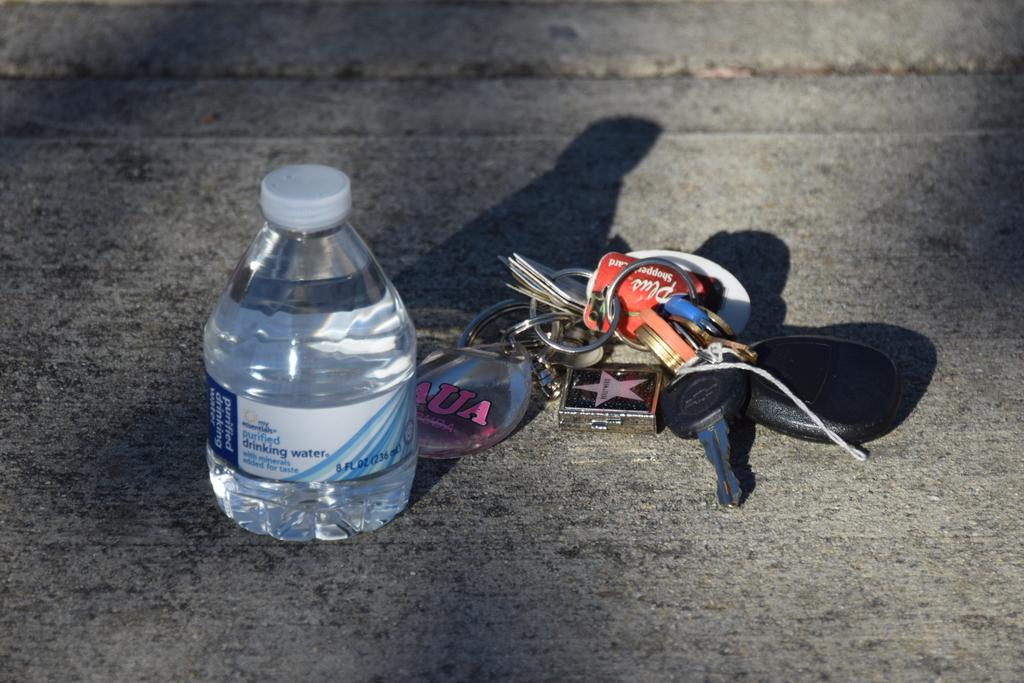What object can be seen in the image that is typically used for holding keys? There is a key chain in the image. What object can be seen in the image that is typically used for holding water? There is a water bottle in the image. Where are the key chain and water bottle located in the image? Both the key chain and the water bottle are placed on the floor. Can you see any rivers or trains in the image? No, there are no rivers or trains present in the image. Is there a shelf visible in the image? No, there is no shelf visible in the image. 